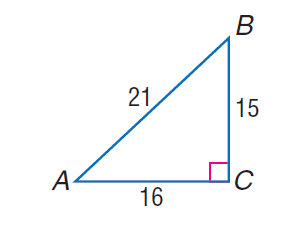Answer the mathemtical geometry problem and directly provide the correct option letter.
Question: find \cos B.
Choices: A: \frac { 5 } { 7 } B: \frac { 16 } { 21 } C: \frac { 15 } { 16 } D: \frac { 16 } { 15 } A 